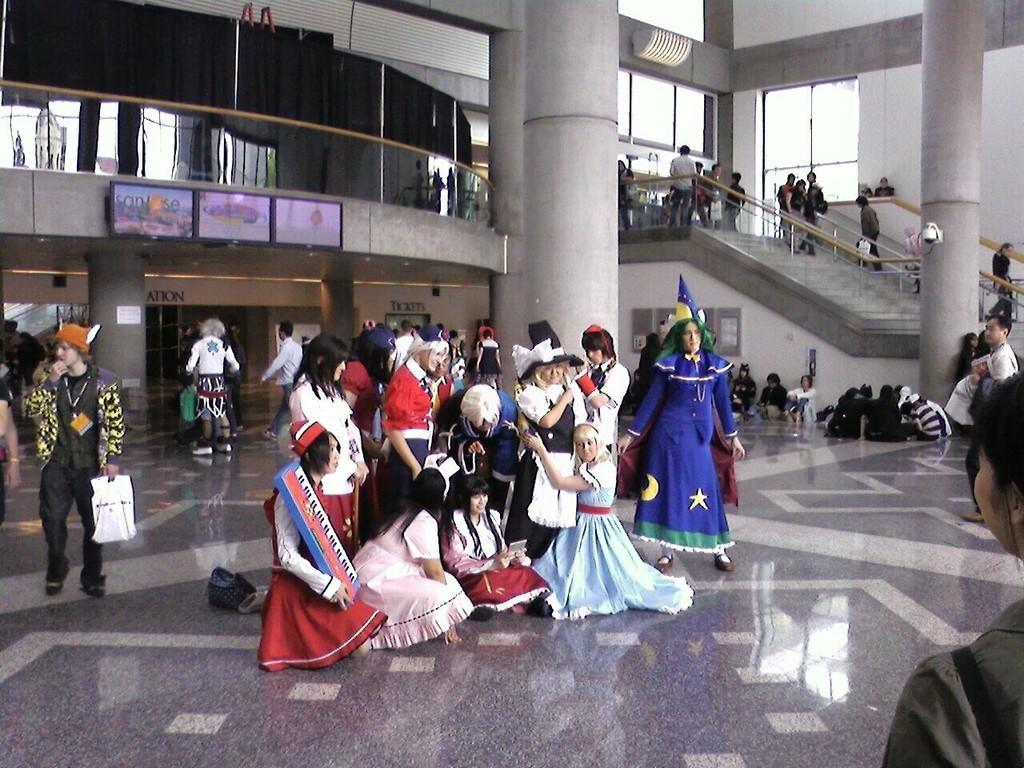Describe this image in one or two sentences. In the middle of the picture, we see women wearing costumes are standing. Behind them, we see a pillar and behind them, we see people are standing. The man on the right side wearing white T-shirt is standing. Beside him, we see people are sitting on the floor. We even see a pillar and a staircase. In the background, we see glass doors and windows. 